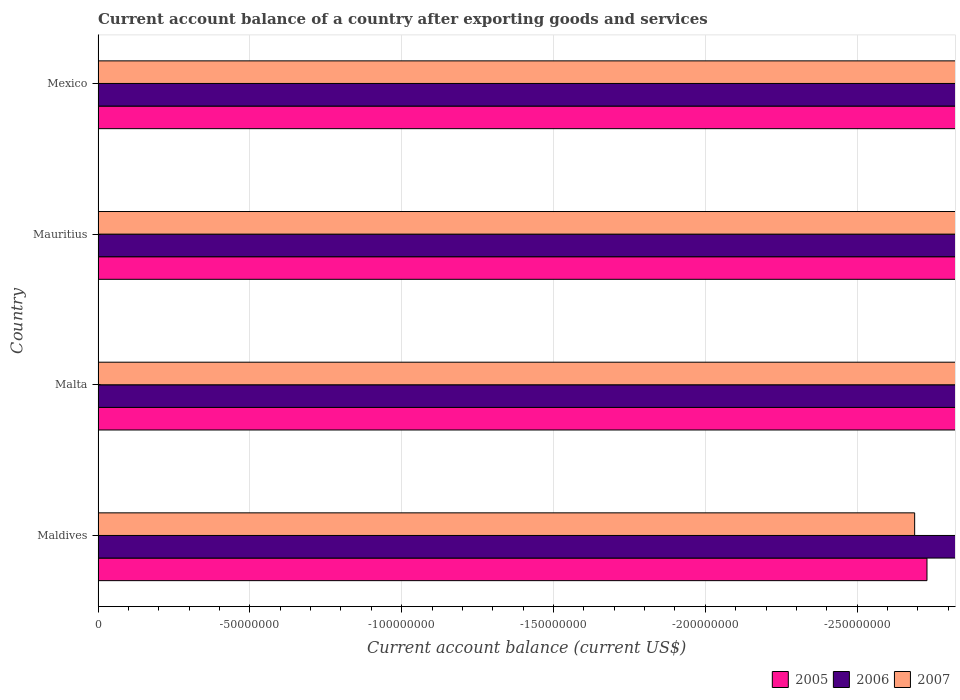What is the label of the 3rd group of bars from the top?
Your answer should be compact. Malta. In how many cases, is the number of bars for a given country not equal to the number of legend labels?
Offer a terse response. 4. Across all countries, what is the minimum account balance in 2005?
Provide a short and direct response. 0. What is the difference between the account balance in 2005 in Malta and the account balance in 2006 in Mexico?
Your response must be concise. 0. In how many countries, is the account balance in 2007 greater than -140000000 US$?
Offer a terse response. 0. In how many countries, is the account balance in 2007 greater than the average account balance in 2007 taken over all countries?
Your answer should be compact. 0. How many bars are there?
Provide a short and direct response. 0. What is the difference between two consecutive major ticks on the X-axis?
Provide a succinct answer. 5.00e+07. How many legend labels are there?
Your answer should be compact. 3. What is the title of the graph?
Provide a short and direct response. Current account balance of a country after exporting goods and services. Does "1971" appear as one of the legend labels in the graph?
Make the answer very short. No. What is the label or title of the X-axis?
Give a very brief answer. Current account balance (current US$). What is the Current account balance (current US$) in 2007 in Maldives?
Keep it short and to the point. 0. What is the Current account balance (current US$) in 2006 in Malta?
Make the answer very short. 0. What is the Current account balance (current US$) of 2007 in Mauritius?
Provide a short and direct response. 0. What is the total Current account balance (current US$) in 2006 in the graph?
Your answer should be very brief. 0. 